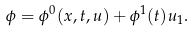<formula> <loc_0><loc_0><loc_500><loc_500>\phi = \phi ^ { 0 } ( x , t , u ) + \phi ^ { 1 } ( t ) u _ { 1 } .</formula> 